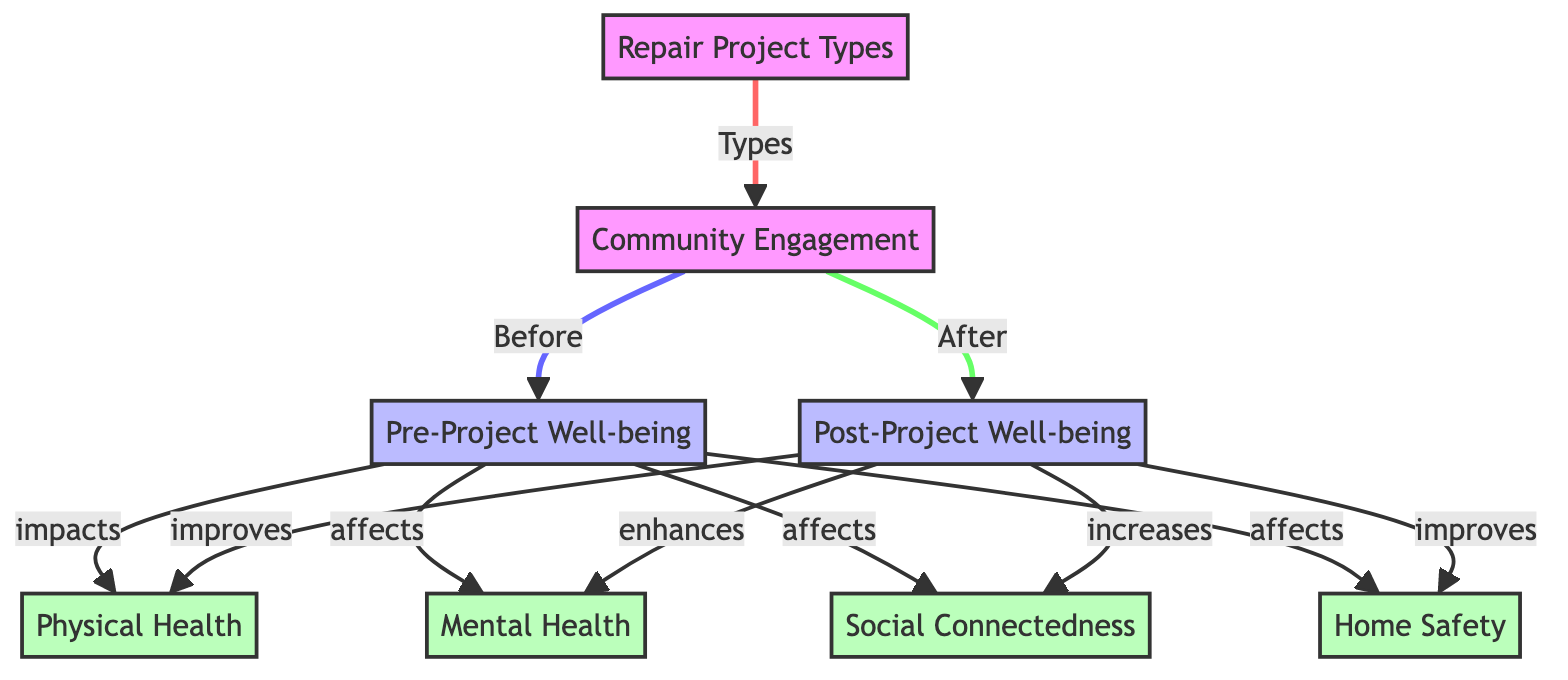What's the total number of nodes in the diagram? The diagram contains nodes for Community Engagement, Repair Project Types, Pre-Project Well-being, Post-Project Well-being, and four impact categories (Physical Health, Mental Health, Social Connectedness, Home Safety), totalling eight nodes.
Answer: 8 What is the relationship between Repair Project Types and Community Engagement? The diagram shows that Repair Project Types influence or lead to Community Engagement, indicated by the arrow connecting these two nodes.
Answer: Types What impacts Pre-Project Well-being? The Pre-Project Well-being node is influenced by Physical Health, Mental Health, Social Connectedness, and Home Safety as indicated by the arrows leading away from the Pre-Project Well-being node.
Answer: Physical Health, Mental Health, Social Connectedness, Home Safety What happens to Physical Health after the project? According to the diagram, Physical Health is improved post-project, as indicated by the arrow from Post-Project Well-being to Physical Health.
Answer: improves How does Community Engagement affect Post-Project Well-being? Community Engagement contributes to Post-Project Well-being, meaning that strong engagement likely enhances overall well-being indicated by the arrow leading from Community Engagement to Post-Project Well-being.
Answer: After What is the improvement in Mental Health associated with Post-Project outcomes? The diagram links Post-Project Well-being to Mental Health, specifically describing the change as an enhancement following the project implementation, thus indicating a positive growth factor.
Answer: enhances How many impacts are listed for Pre-Project Well-being? There are four impacts listed for Pre-Project Well-being: Physical Health, Mental Health, Social Connectedness, and Home Safety, all of which are clearly shown as having an effect on Pre-Project Well-being.
Answer: 4 Which aspects of well-being experience an increase post-project? The Post-Project Well-being leads to increased Social Connectedness as indicated by the specific arrow. It also leads to improvements in Physical Health and Home Safety, all indicating a positive trend after the project.
Answer: Social Connectedness What does the flow direction indicate regarding the impact of Repair Project Types on the community? The arrows in the diagram indicate that Repair Project Types are the starting point, suggesting that they initiate the process of enhancing community engagement, which in turn affects well-being and impacts various health domains.
Answer: Initiates 